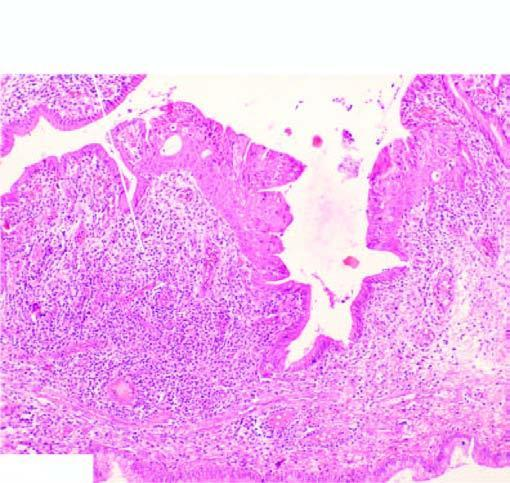what is lined by normal columnar epithelium while foci of metaplastic squamous epithelium are seen at other places?
Answer the question using a single word or phrase. Part of the endocervical mucosa 